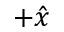Convert formula to latex. <formula><loc_0><loc_0><loc_500><loc_500>+ \hat { x }</formula> 